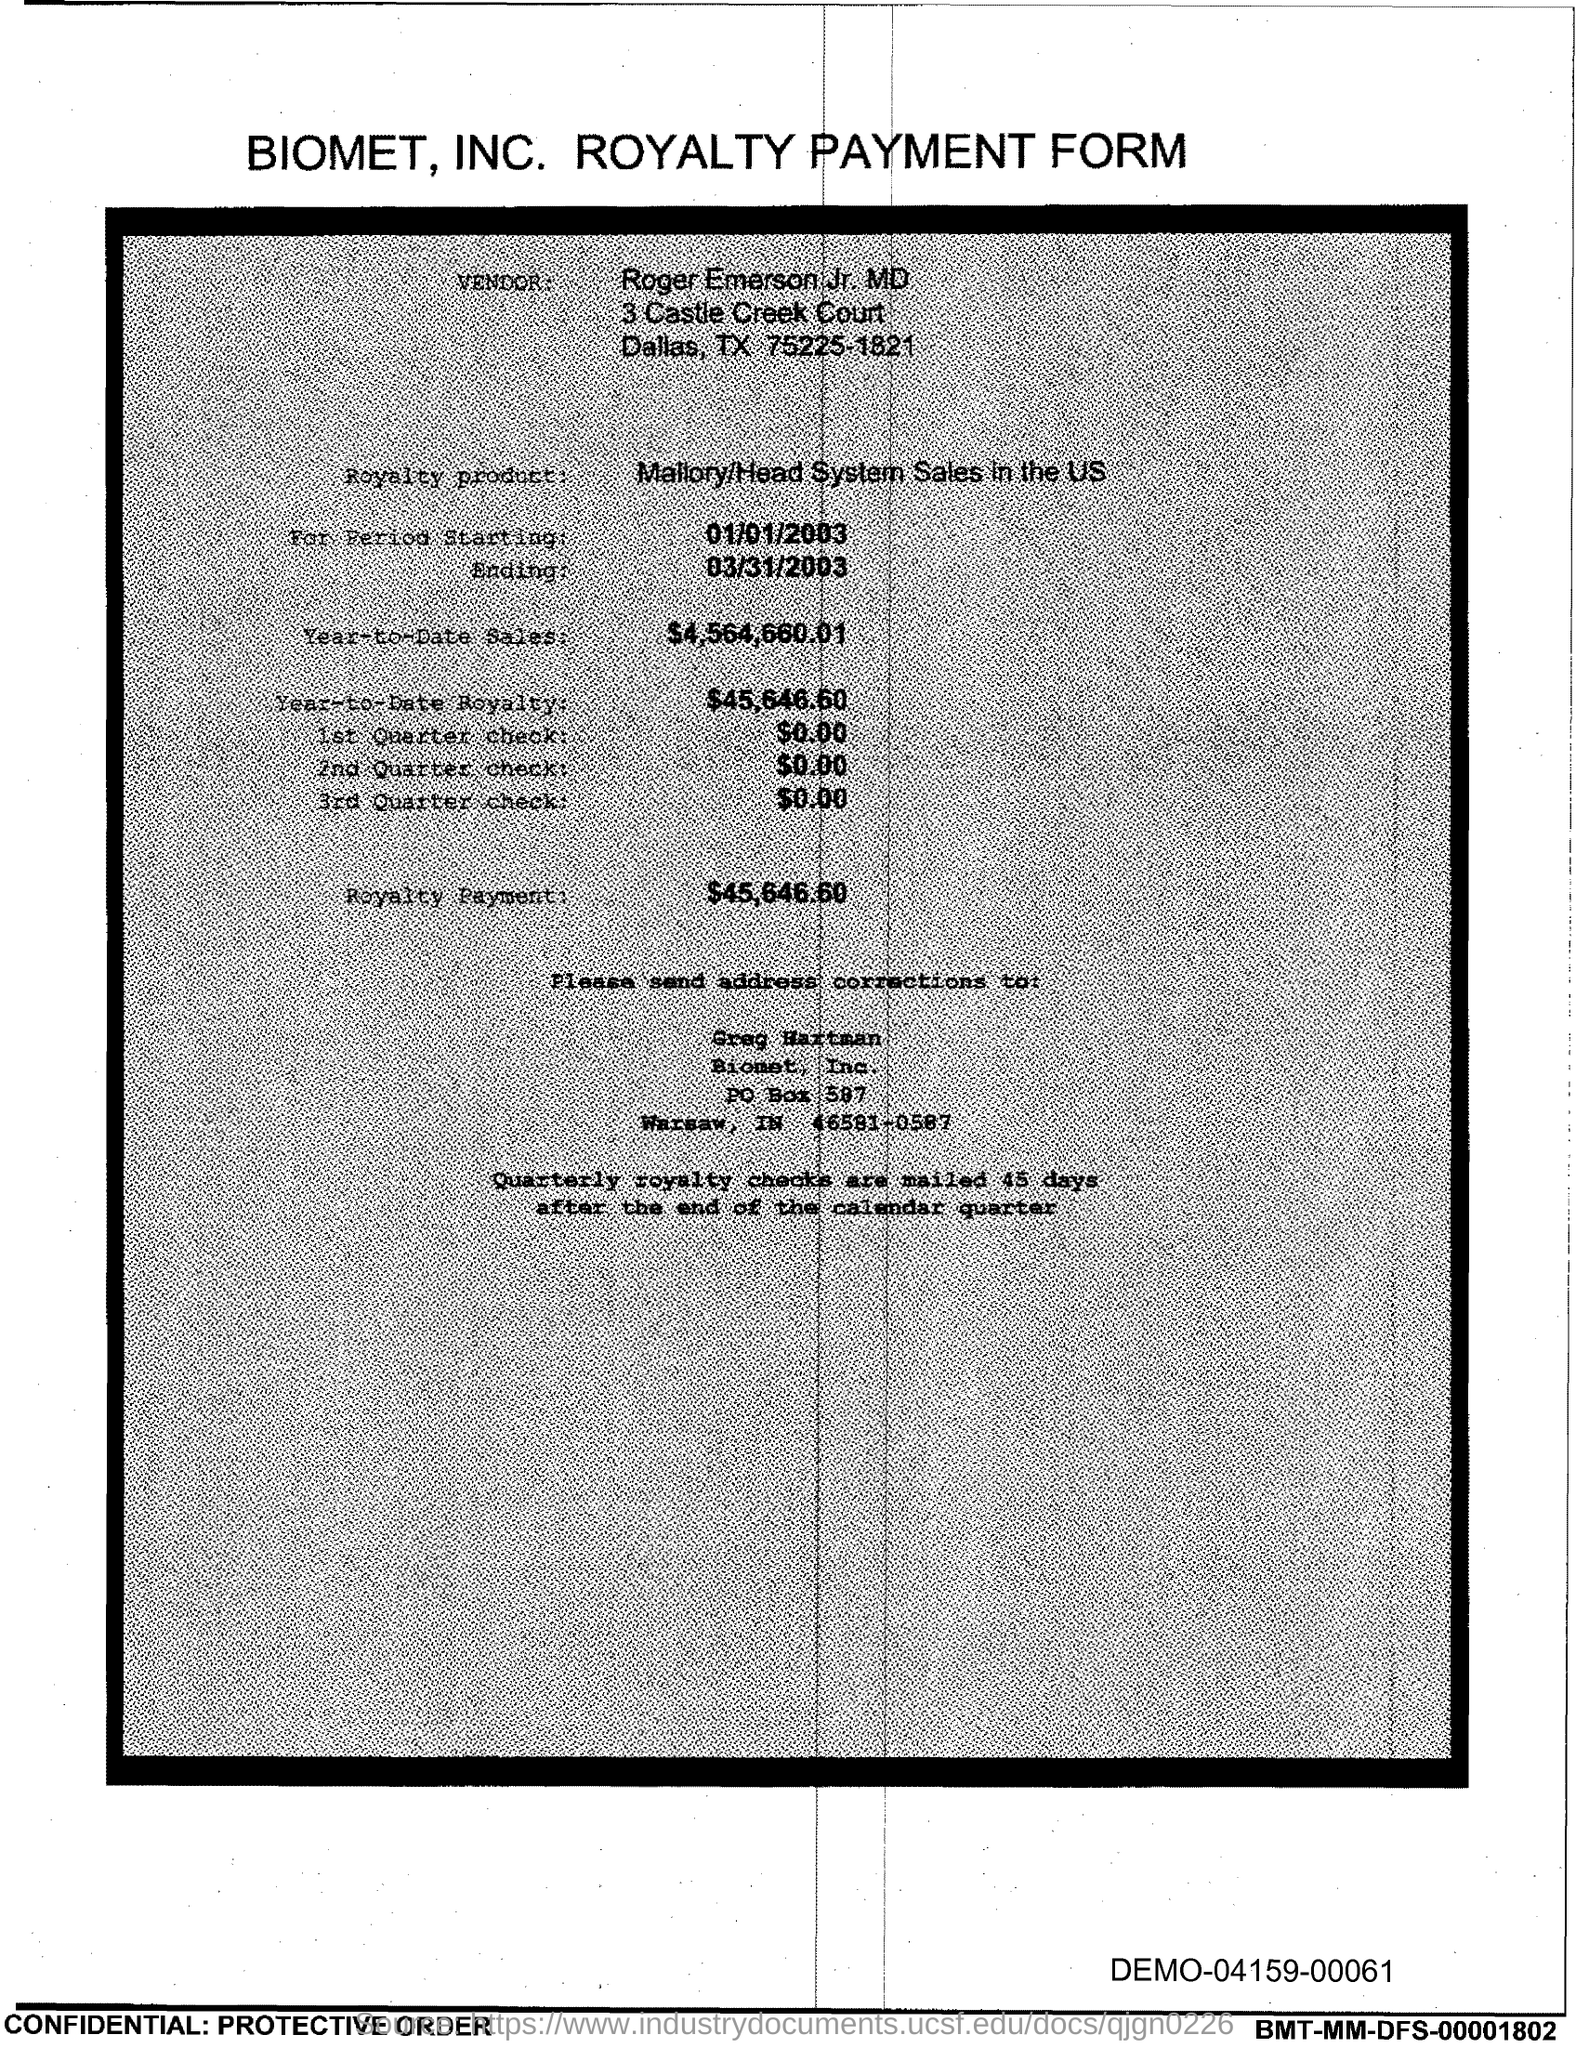Draw attention to some important aspects in this diagram. The year-to-date sales of the royalty product are $4,564,660.01. The given name of the vendor is "Roger Emerson Jr. MD. The amount of the 1st quarter check mentioned in the form is $0.00. The end date of the royalty period is March 31, 2003. The royalty payment for the product mentioned in the form is $45,646.60. 